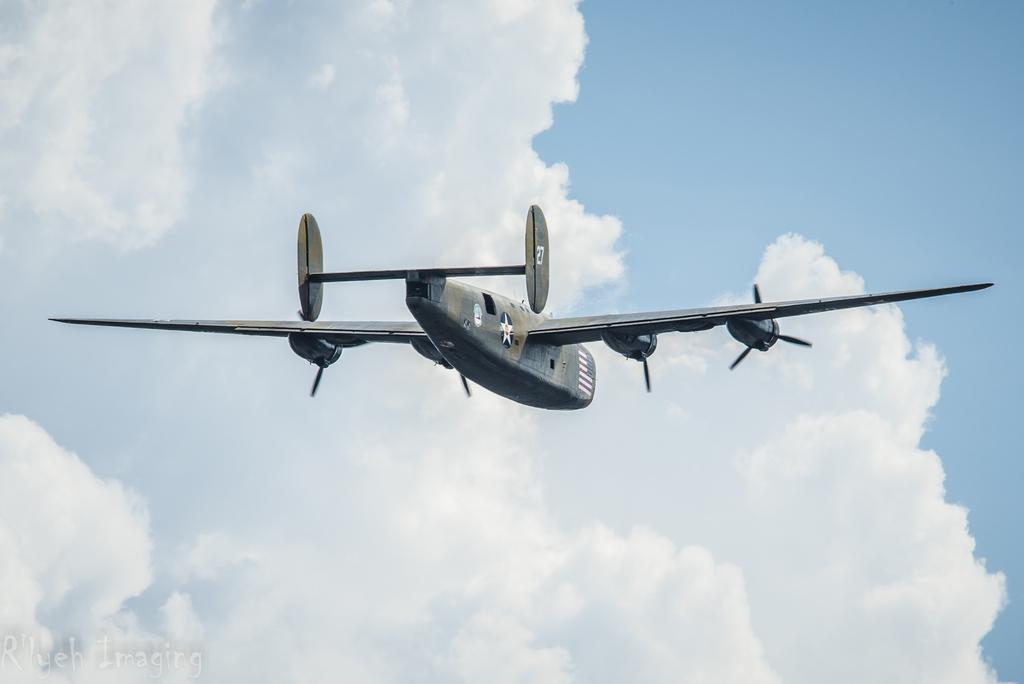What is the main subject of the image? The main subject of the image is an aircraft. What colors are used to paint the aircraft? The aircraft is grey and white in color. What is the aircraft doing in the image? The aircraft is flying in the air. What can be seen in the background of the image? The sky is visible in the background of the image. What colors are present in the sky? The sky is blue and white in color. Can you see a monkey climbing on the aircraft in the image? No, there is no monkey present in the image. What type of error is the aircraft making in the image? There is no indication of any error being made by the aircraft in the image. 